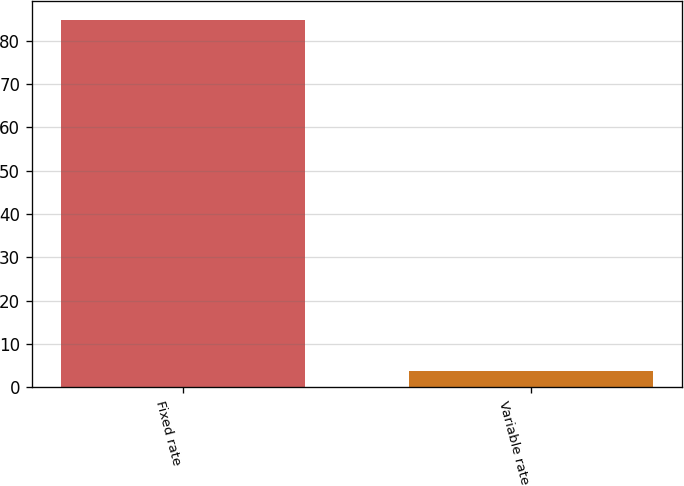Convert chart. <chart><loc_0><loc_0><loc_500><loc_500><bar_chart><fcel>Fixed rate<fcel>Variable rate<nl><fcel>84.9<fcel>3.8<nl></chart> 